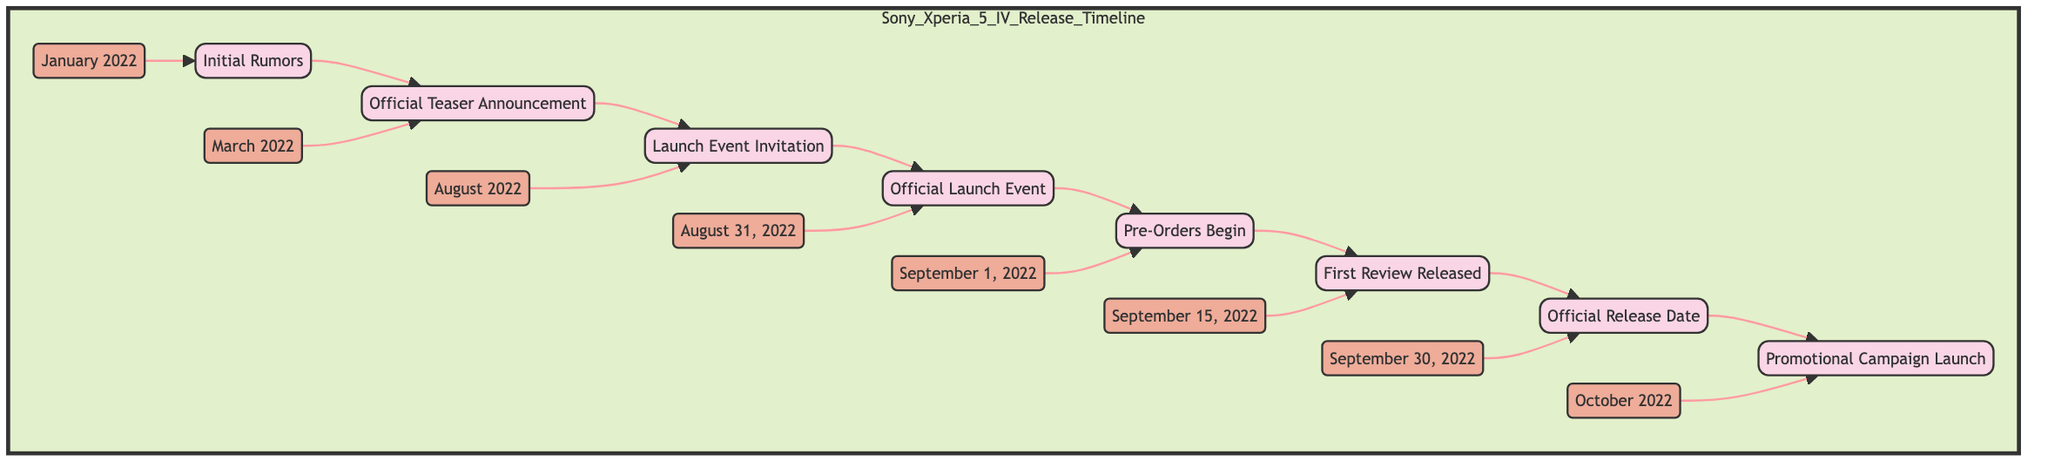What is the first event in the timeline? The first event in the timeline is "Initial Rumors." This can be identified as the first node in the flowchart, labeled "Initial Rumors."
Answer: Initial Rumors What date corresponds to the "Official Teaser Announcement"? The "Official Teaser Announcement" is represented with a date node connected to it, which shows "March 2022."
Answer: March 2022 How many events are in the timeline? Counting each event listed in the flowchart, there are a total of eight events outlined in the timeline: Initial Rumors, Official Teaser Announcement, Launch Event Invitation, Official Launch Event, Pre-Orders Begin, First Review Released, Official Release Date, and Promotional Campaign Launch.
Answer: 8 What event happens immediately after "Pre-Orders Begin"? Looking at the flowchart, the event that follows "Pre-Orders Begin" is "First Review Released." This indicates that they are sequentially connected.
Answer: First Review Released Which month sees the "Official Release Date"? The "Official Release Date" is marked in the flowchart with a date node leading to it, showing "September 30, 2022."
Answer: September 30, 2022 What was the last promotional activity listed in the timeline? The last promotional activity in the timeline is the "Promotional Campaign Launch." It is the final node in the flowchart, indicating it is the last event in the sequence.
Answer: Promotional Campaign Launch Which event was held on August 31, 2022? The event corresponding to that date is the "Official Launch Event." The flowchart links this event specifically to the date mentioned.
Answer: Official Launch Event What two events were associated with the month of September 2022? The two events in September are "Pre-Orders Begin" on September 1 and "Official Release Date" on September 30. Both are sequentially shown in the flowchart.
Answer: Pre-Orders Begin and Official Release Date 